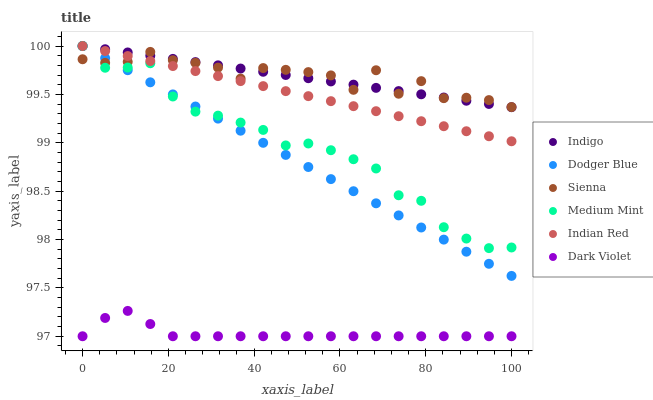Does Dark Violet have the minimum area under the curve?
Answer yes or no. Yes. Does Sienna have the maximum area under the curve?
Answer yes or no. Yes. Does Indigo have the minimum area under the curve?
Answer yes or no. No. Does Indigo have the maximum area under the curve?
Answer yes or no. No. Is Dodger Blue the smoothest?
Answer yes or no. Yes. Is Sienna the roughest?
Answer yes or no. Yes. Is Indigo the smoothest?
Answer yes or no. No. Is Indigo the roughest?
Answer yes or no. No. Does Dark Violet have the lowest value?
Answer yes or no. Yes. Does Indigo have the lowest value?
Answer yes or no. No. Does Indian Red have the highest value?
Answer yes or no. Yes. Does Dark Violet have the highest value?
Answer yes or no. No. Is Dark Violet less than Indian Red?
Answer yes or no. Yes. Is Sienna greater than Dark Violet?
Answer yes or no. Yes. Does Indian Red intersect Medium Mint?
Answer yes or no. Yes. Is Indian Red less than Medium Mint?
Answer yes or no. No. Is Indian Red greater than Medium Mint?
Answer yes or no. No. Does Dark Violet intersect Indian Red?
Answer yes or no. No. 